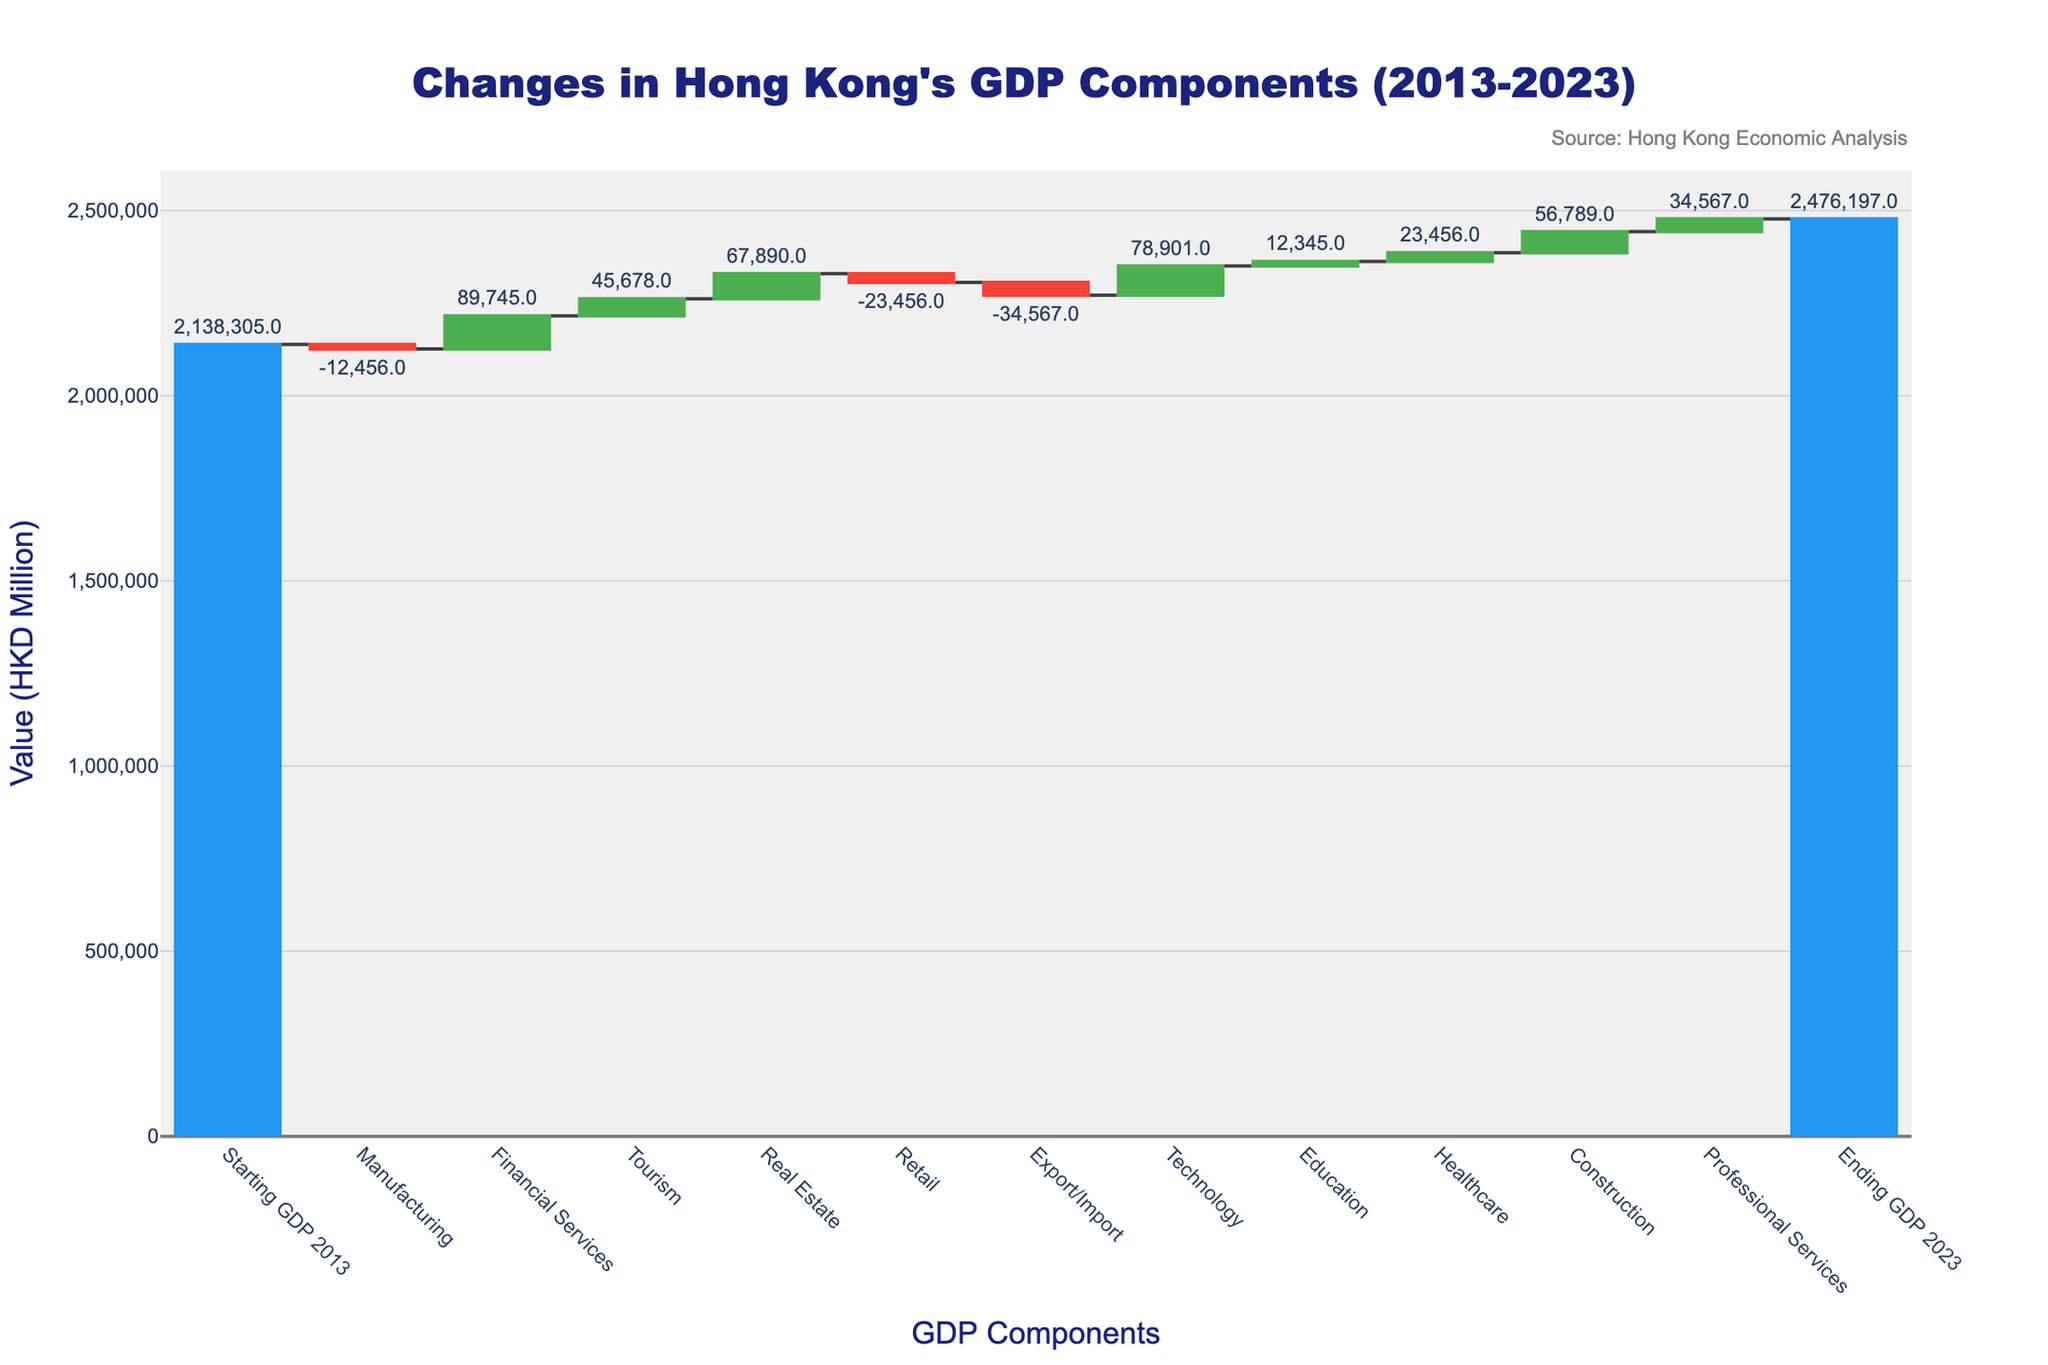What is the total increment contributed by Technology to Hong Kong's GDP from 2013 to 2023? The value for Technology increment on the figure is +78,901 million HKD.
Answer: +78,901 million HKD Which sector showed the highest decline in GDP contribution? By observing the category values, Export/Import shows the highest decline at -34,567 million HKD.
Answer: Export/Import What is the difference between the contributions of Financial Services and Retail to the GDP? Financial Services contributed +89,745 million HKD while Retail contributed -23,456 million HKD. The difference is 89,745 - (-23,456) = 113,201 million HKD.
Answer: 113,201 million HKD Which sectors had positive contributions and which had negative contributions? The positive contributions came from Financial Services, Tourism, Real Estate, Technology, Education, Healthcare, Construction, and Professional Services. Negative contributions came from Manufacturing, Retail, and Export/Import.
Answer: Positive: Financial Services, Tourism, Real Estate, Technology, Education, Healthcare, Construction, Professional Services; Negative: Manufacturing, Retail, Export/Import How much did the GDP increase from 2013 to 2023 in total? Starting GDP in 2013 was 2,138,305 million HKD and the ending GDP in 2023 was 2,476,197 million HKD. The increase is 2,476,197 - 2,138,305 = 337,892 million HKD.
Answer: 337,892 million HKD Which sector added the smallest positive value to Hong Kong's GDP? According to the data for positive contributions, Education added the smallest positive value of +12,345 million HKD.
Answer: Education What was the cumulative effect of negative contributions on the GDP? The cumulative sum of the negative contributions: Manufacturing (-12,456) + Retail (-23,456) + Export/Import (-34,567) = -70,479 million HKD.
Answer: -70,479 million HKD Between Tourism and Real Estate, which sector had a greater impact on increasing the GDP? Tourism has a contribution of +45,678 million HKD and Real Estate has a contribution of +67,890 million HKD. Real Estate had the greater impact.
Answer: Real Estate What is the visual indicator used to represent decreasing components in the chart? Decreasing components in the chart are represented using the red color.
Answer: Red color What is the total contribution by all sectors combined except for the base year's GDP? The sum of all sector contributions from the figure: (-12,456 + 89,745 + 45,678 + 67,890 - 23,456 - 34,567 + 78,901 + 12,345 + 23,456 + 56,789 + 34,567) = 338,892 million HKD.
Answer: 338,892 million HKD 